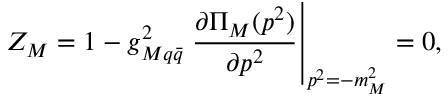Convert formula to latex. <formula><loc_0><loc_0><loc_500><loc_500>Z _ { M } = 1 - g _ { M q \bar { q } } ^ { 2 } \frac { \partial { \Pi } _ { M } ( p ^ { 2 } ) } { \partial p ^ { 2 } } \right | _ { p ^ { 2 } = - m _ { M } ^ { 2 } } = 0 ,</formula> 